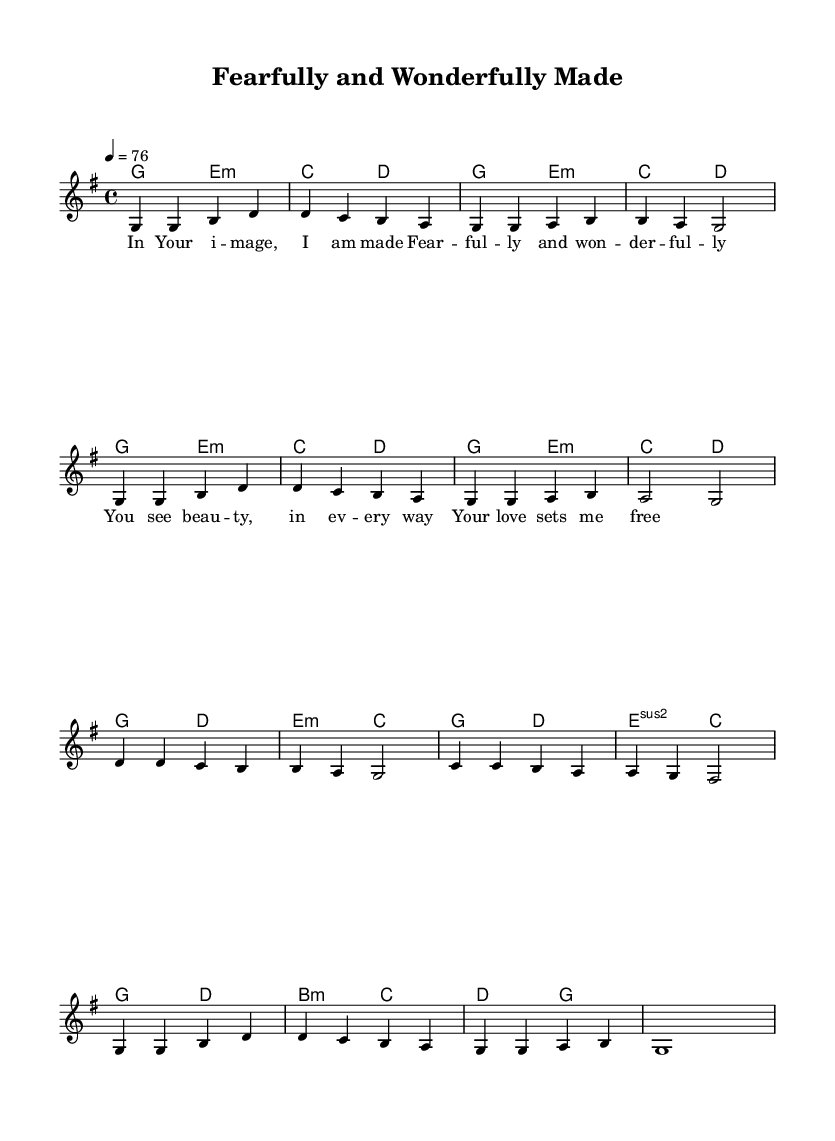What is the key signature of this music? The key signature is G major, which has one sharp (F#).
Answer: G major What is the time signature of this music? The time signature is 4/4, meaning there are four beats in each measure.
Answer: 4/4 What is the tempo marking of this piece? The tempo marking indicates a speed of 76 beats per minute (4 = 76).
Answer: 76 How many measures are in the first section of music? The first section has 8 measures, counting them in the melody part before it repeats.
Answer: 8 What lyrical theme does this song primarily express? The lyrical theme expresses self-love and acceptance as part of God's creation.
Answer: Self-love and acceptance Which chords are used in the first measure? The first measure uses the G chord as indicated in the chord names.
Answer: G How does the structure of verses relate to the overall message of the song? The structure reinforces the message of being beautifully made in God's image, which promotes body positivity and self-acceptance.
Answer: Body positivity and self-acceptance 